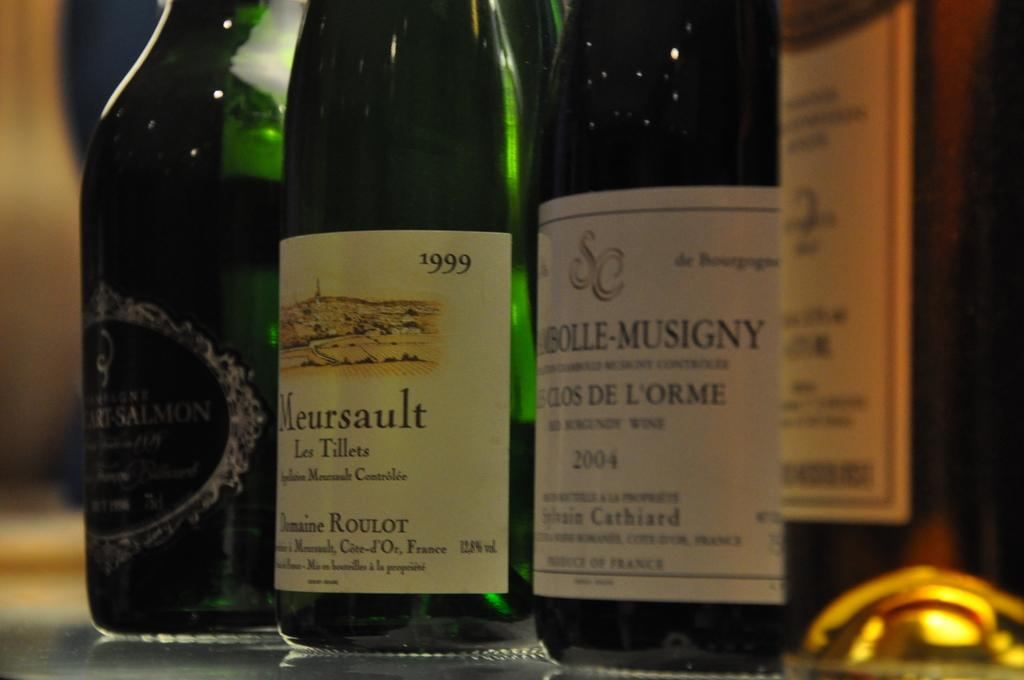<image>
Write a terse but informative summary of the picture. Several bottles of wine including a bottle of Meursault. 